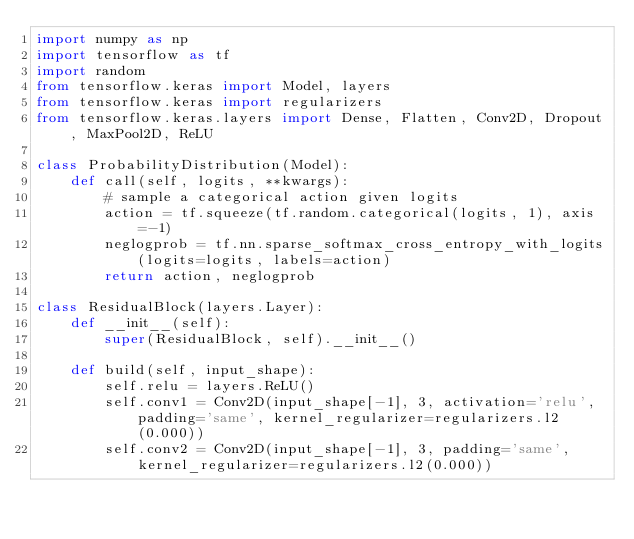Convert code to text. <code><loc_0><loc_0><loc_500><loc_500><_Python_>import numpy as np
import tensorflow as tf
import random
from tensorflow.keras import Model, layers
from tensorflow.keras import regularizers
from tensorflow.keras.layers import Dense, Flatten, Conv2D, Dropout, MaxPool2D, ReLU

class ProbabilityDistribution(Model):
    def call(self, logits, **kwargs):
        # sample a categorical action given logits
        action = tf.squeeze(tf.random.categorical(logits, 1), axis=-1)
        neglogprob = tf.nn.sparse_softmax_cross_entropy_with_logits(logits=logits, labels=action)
        return action, neglogprob

class ResidualBlock(layers.Layer):
    def __init__(self):
        super(ResidualBlock, self).__init__()
        
    def build(self, input_shape):
        self.relu = layers.ReLU()
        self.conv1 = Conv2D(input_shape[-1], 3, activation='relu', padding='same', kernel_regularizer=regularizers.l2(0.000))
        self.conv2 = Conv2D(input_shape[-1], 3, padding='same', kernel_regularizer=regularizers.l2(0.000))
</code> 